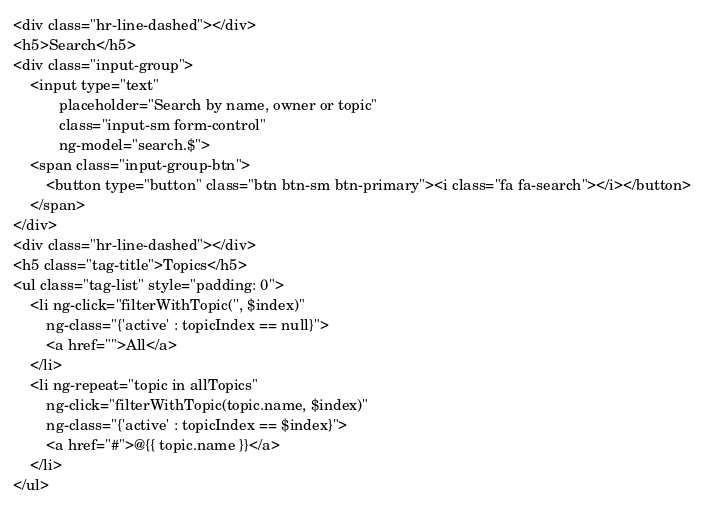<code> <loc_0><loc_0><loc_500><loc_500><_PHP_><div class="hr-line-dashed"></div>
<h5>Search</h5>
<div class="input-group">
    <input type="text"
           placeholder="Search by name, owner or topic"
           class="input-sm form-control"
           ng-model="search.$">
    <span class="input-group-btn">
        <button type="button" class="btn btn-sm btn-primary"><i class="fa fa-search"></i></button>
    </span>
</div>
<div class="hr-line-dashed"></div>
<h5 class="tag-title">Topics</h5>
<ul class="tag-list" style="padding: 0">
    <li ng-click="filterWithTopic('', $index)"
        ng-class="{'active' : topicIndex == null}">
        <a href="">All</a>
    </li>
    <li ng-repeat="topic in allTopics"
        ng-click="filterWithTopic(topic.name, $index)"
        ng-class="{'active' : topicIndex == $index}">
        <a href="#">@{{ topic.name }}</a>
    </li>
</ul></code> 